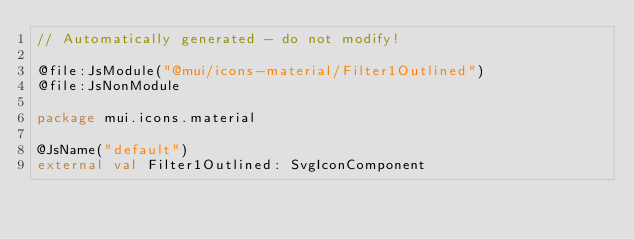Convert code to text. <code><loc_0><loc_0><loc_500><loc_500><_Kotlin_>// Automatically generated - do not modify!

@file:JsModule("@mui/icons-material/Filter1Outlined")
@file:JsNonModule

package mui.icons.material

@JsName("default")
external val Filter1Outlined: SvgIconComponent
</code> 